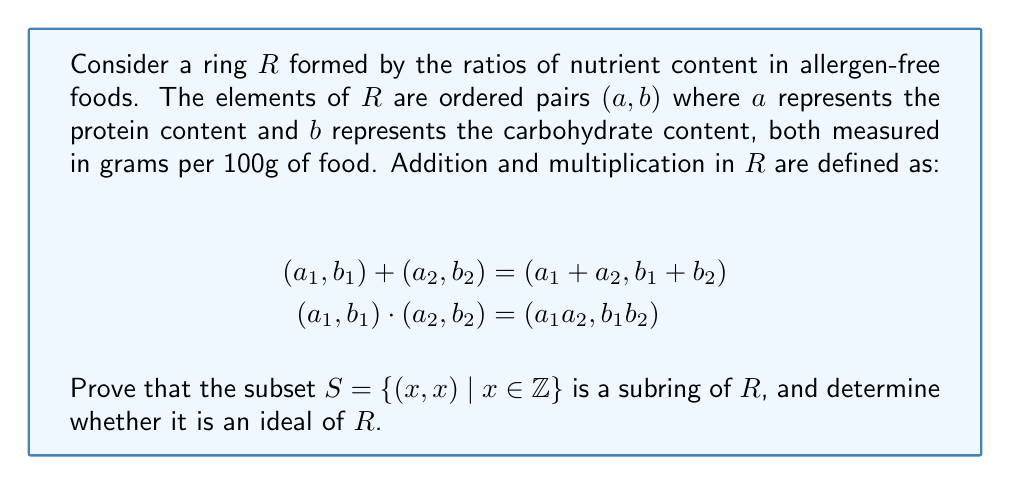Can you solve this math problem? To prove that $S$ is a subring of $R$, we need to show that it is closed under addition and multiplication, contains the additive identity, and for each element, its additive inverse is also in $S$.

1. Closure under addition:
   Let $(x,x), (y,y) \in S$. Then $(x,x) + (y,y) = (x+y, x+y) \in S$

2. Closure under multiplication:
   Let $(x,x), (y,y) \in S$. Then $(x,x) \cdot (y,y) = (xy, xy) \in S$

3. Additive identity:
   The additive identity of $R$ is $(0,0)$, which is in $S$

4. Additive inverse:
   For any $(x,x) \in S$, its additive inverse is $(-x,-x)$, which is also in $S$

Therefore, $S$ is a subring of $R$.

To determine whether $S$ is an ideal of $R$, we need to check if for all $s \in S$ and $r \in R$, both $rs$ and $sr$ are in $S$.

Let $s = (x,x) \in S$ and $r = (a,b) \in R$:

$rs = (a,b) \cdot (x,x) = (ax,bx)$
$sr = (x,x) \cdot (a,b) = (ax,bx)$

For $(ax,bx)$ to be in $S$, we must have $ax = bx$ for all $x \in \mathbb{Z}$. This is only true when $a = b$, which is not the case for all elements in $R$.

Therefore, $S$ is not an ideal of $R$.
Answer: $S$ is a subring of $R$, but it is not an ideal of $R$. 